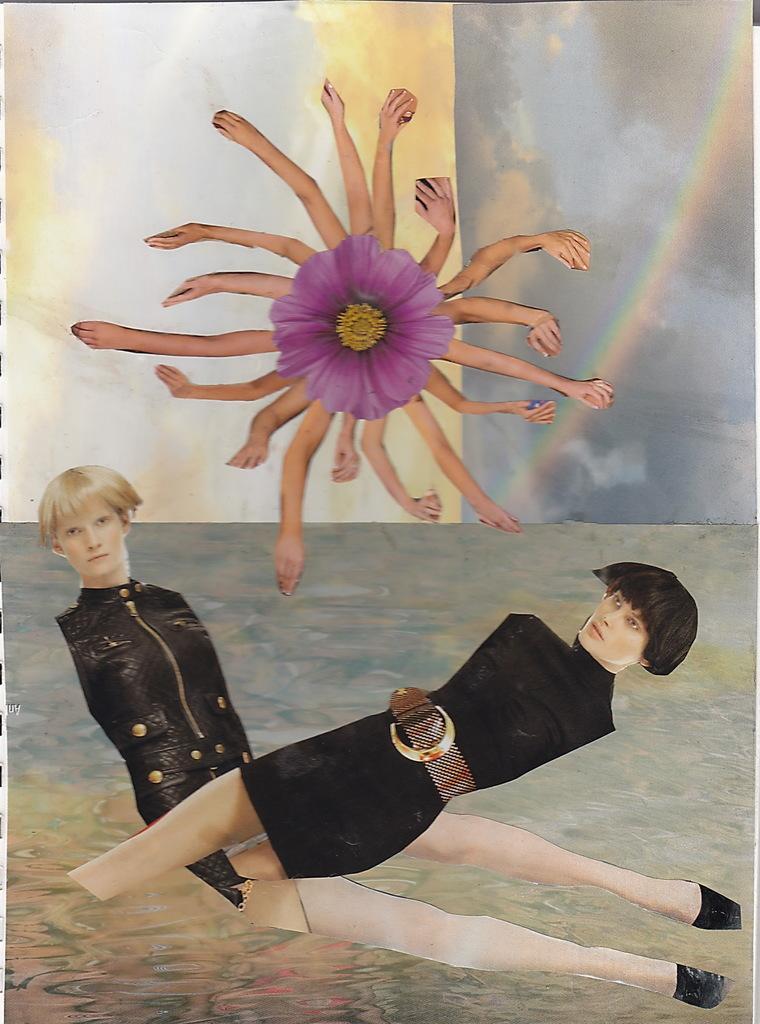Can you describe this image briefly? This is an edited image. There are two cuttings of persons in the image. Here there are many hands around a purple flower. This is the background. These all are made up of paper cuttings. 